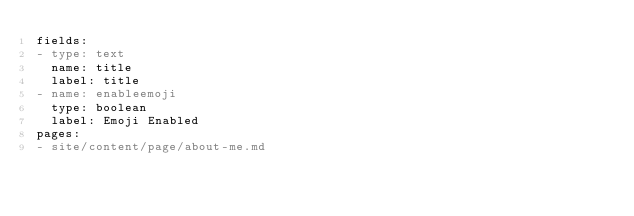<code> <loc_0><loc_0><loc_500><loc_500><_YAML_>fields:
- type: text
  name: title
  label: title
- name: enableemoji
  type: boolean
  label: Emoji Enabled
pages:
- site/content/page/about-me.md
</code> 